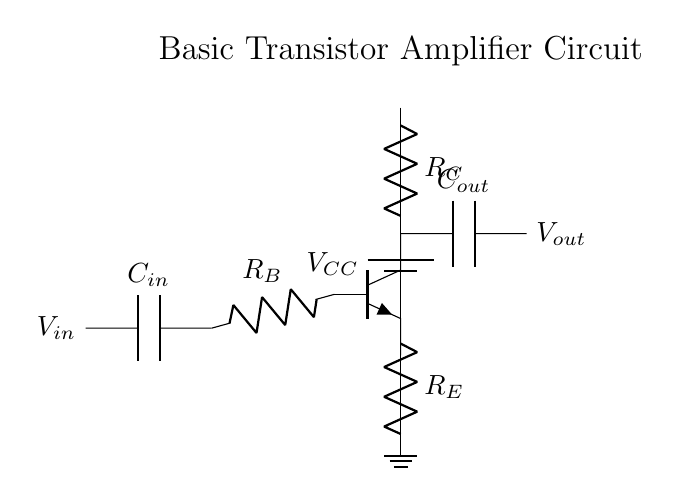What is the power supply voltage? The power supply is labeled as VCC in the circuit diagram. Power supply voltages are typically shown near the battery symbol, indicating the voltage being supplied to the circuit.
Answer: VCC What is the function of the capacitor C_in? Capacitor C_in is connected to the input side of the circuit, allowing AC signals to pass while blocking DC, making it suitable for coupling purposes in amplifying small signals.
Answer: Coupling What type of transistor is used in this circuit? The circuit diagram shows an NPN transistor, which is identified by the npn notation used in the schematic. This type of transistor is commonly used for amplification applications.
Answer: NPN What is the role of the resistor R_E? Resistor R_E is connected to the emitter of the transistor and is used to stabilize the operation of the transistor, affecting the gain and providing thermal stability.
Answer: Stability How does the output capacitor C_out affect the signal? The output capacitor C_out allows the amplified AC signal to pass to the output while blocking any DC component present, ensuring that the output signal conforms to AC characteristics.
Answer: AC coupling What change occurs in V_out if the resistance R_C is increased? Increasing R_C would typically decrease the collector current, which in turn could lead to a reduction in V_out due to Ohm's law (V = IR). This involves examining the relationships between the resistor values and the voltages in the circuit.
Answer: Decrease What is the purpose of the input capacitor C_in in terms of frequency response? C_in creates a high-pass filter effect when paired with the resistor R_B, which allows signals above a certain cutoff frequency to pass while attenuating signals lower than that frequency, impacting the overall frequency response of the amplifier.
Answer: High-pass filter 